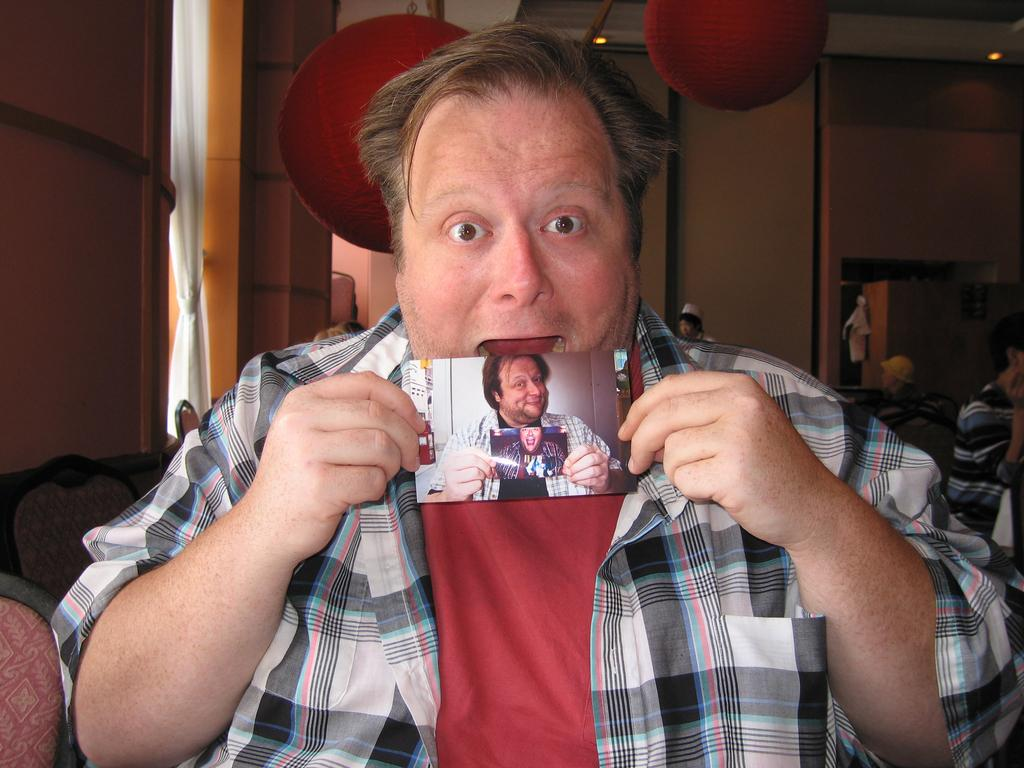Who or what can be seen in the image? There are people in the image. What furniture is present in the image? There are chairs in the image. What object in the image might be used for displaying memories or artwork? There is a photograph in the image. What architectural feature is visible on the left side of the image? There is a window on the left side of the image. What type of window treatment is present in the image? There is a curtain associated with the window. What type of lighting is present in the image? There is a hanging lamp and a ceiling with lights in the image. What type of wax can be seen melting on the floor in the image? There is no wax present in the image, so it cannot be melting on the floor. 